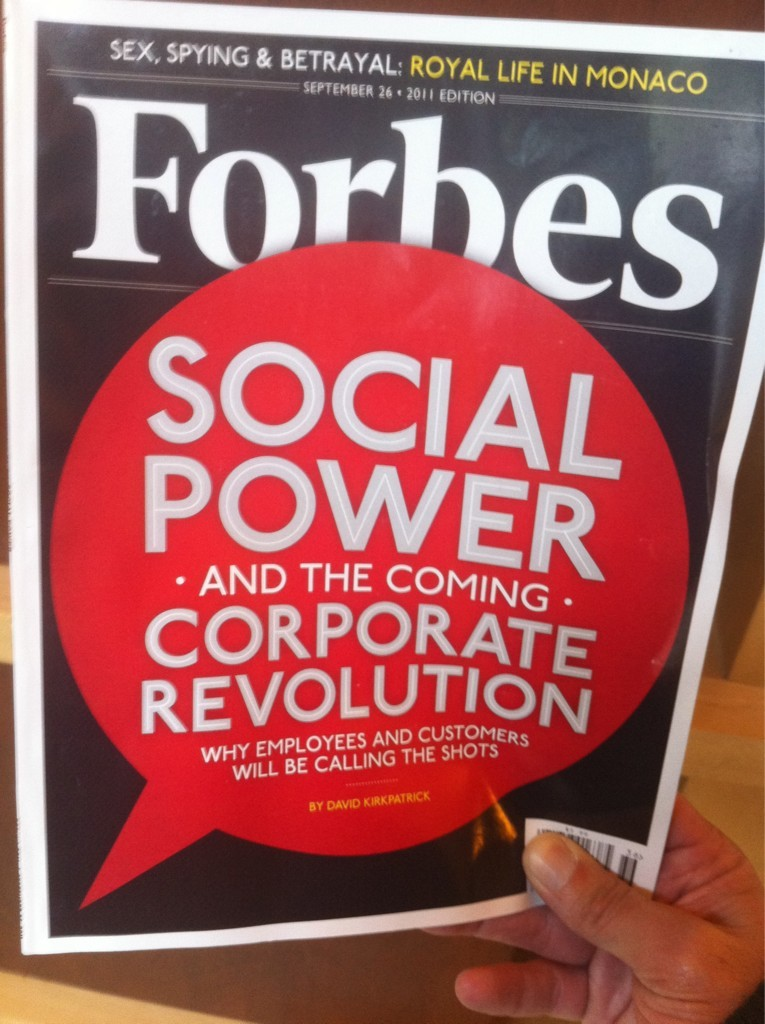What implications might the 'corporate revolution' mentioned on the cover have for typical businesses? The 'corporate revolution' could signify a shift towards more inclusive and transparent business practices where employees and customers have significant influence on company decisions. This could lead to more democratic workplaces and customer-centric business models, ultimately affecting leadership styles, corporate cultures, and possibly even business strategies focused on long-term sustainability and ethical considerations. 